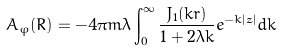<formula> <loc_0><loc_0><loc_500><loc_500>A _ { \varphi } ( { R } ) = - 4 \pi m \lambda \int _ { 0 } ^ { \infty } \frac { J _ { 1 } ( k r ) } { 1 + 2 \lambda k } e ^ { - k | z | } d k</formula> 